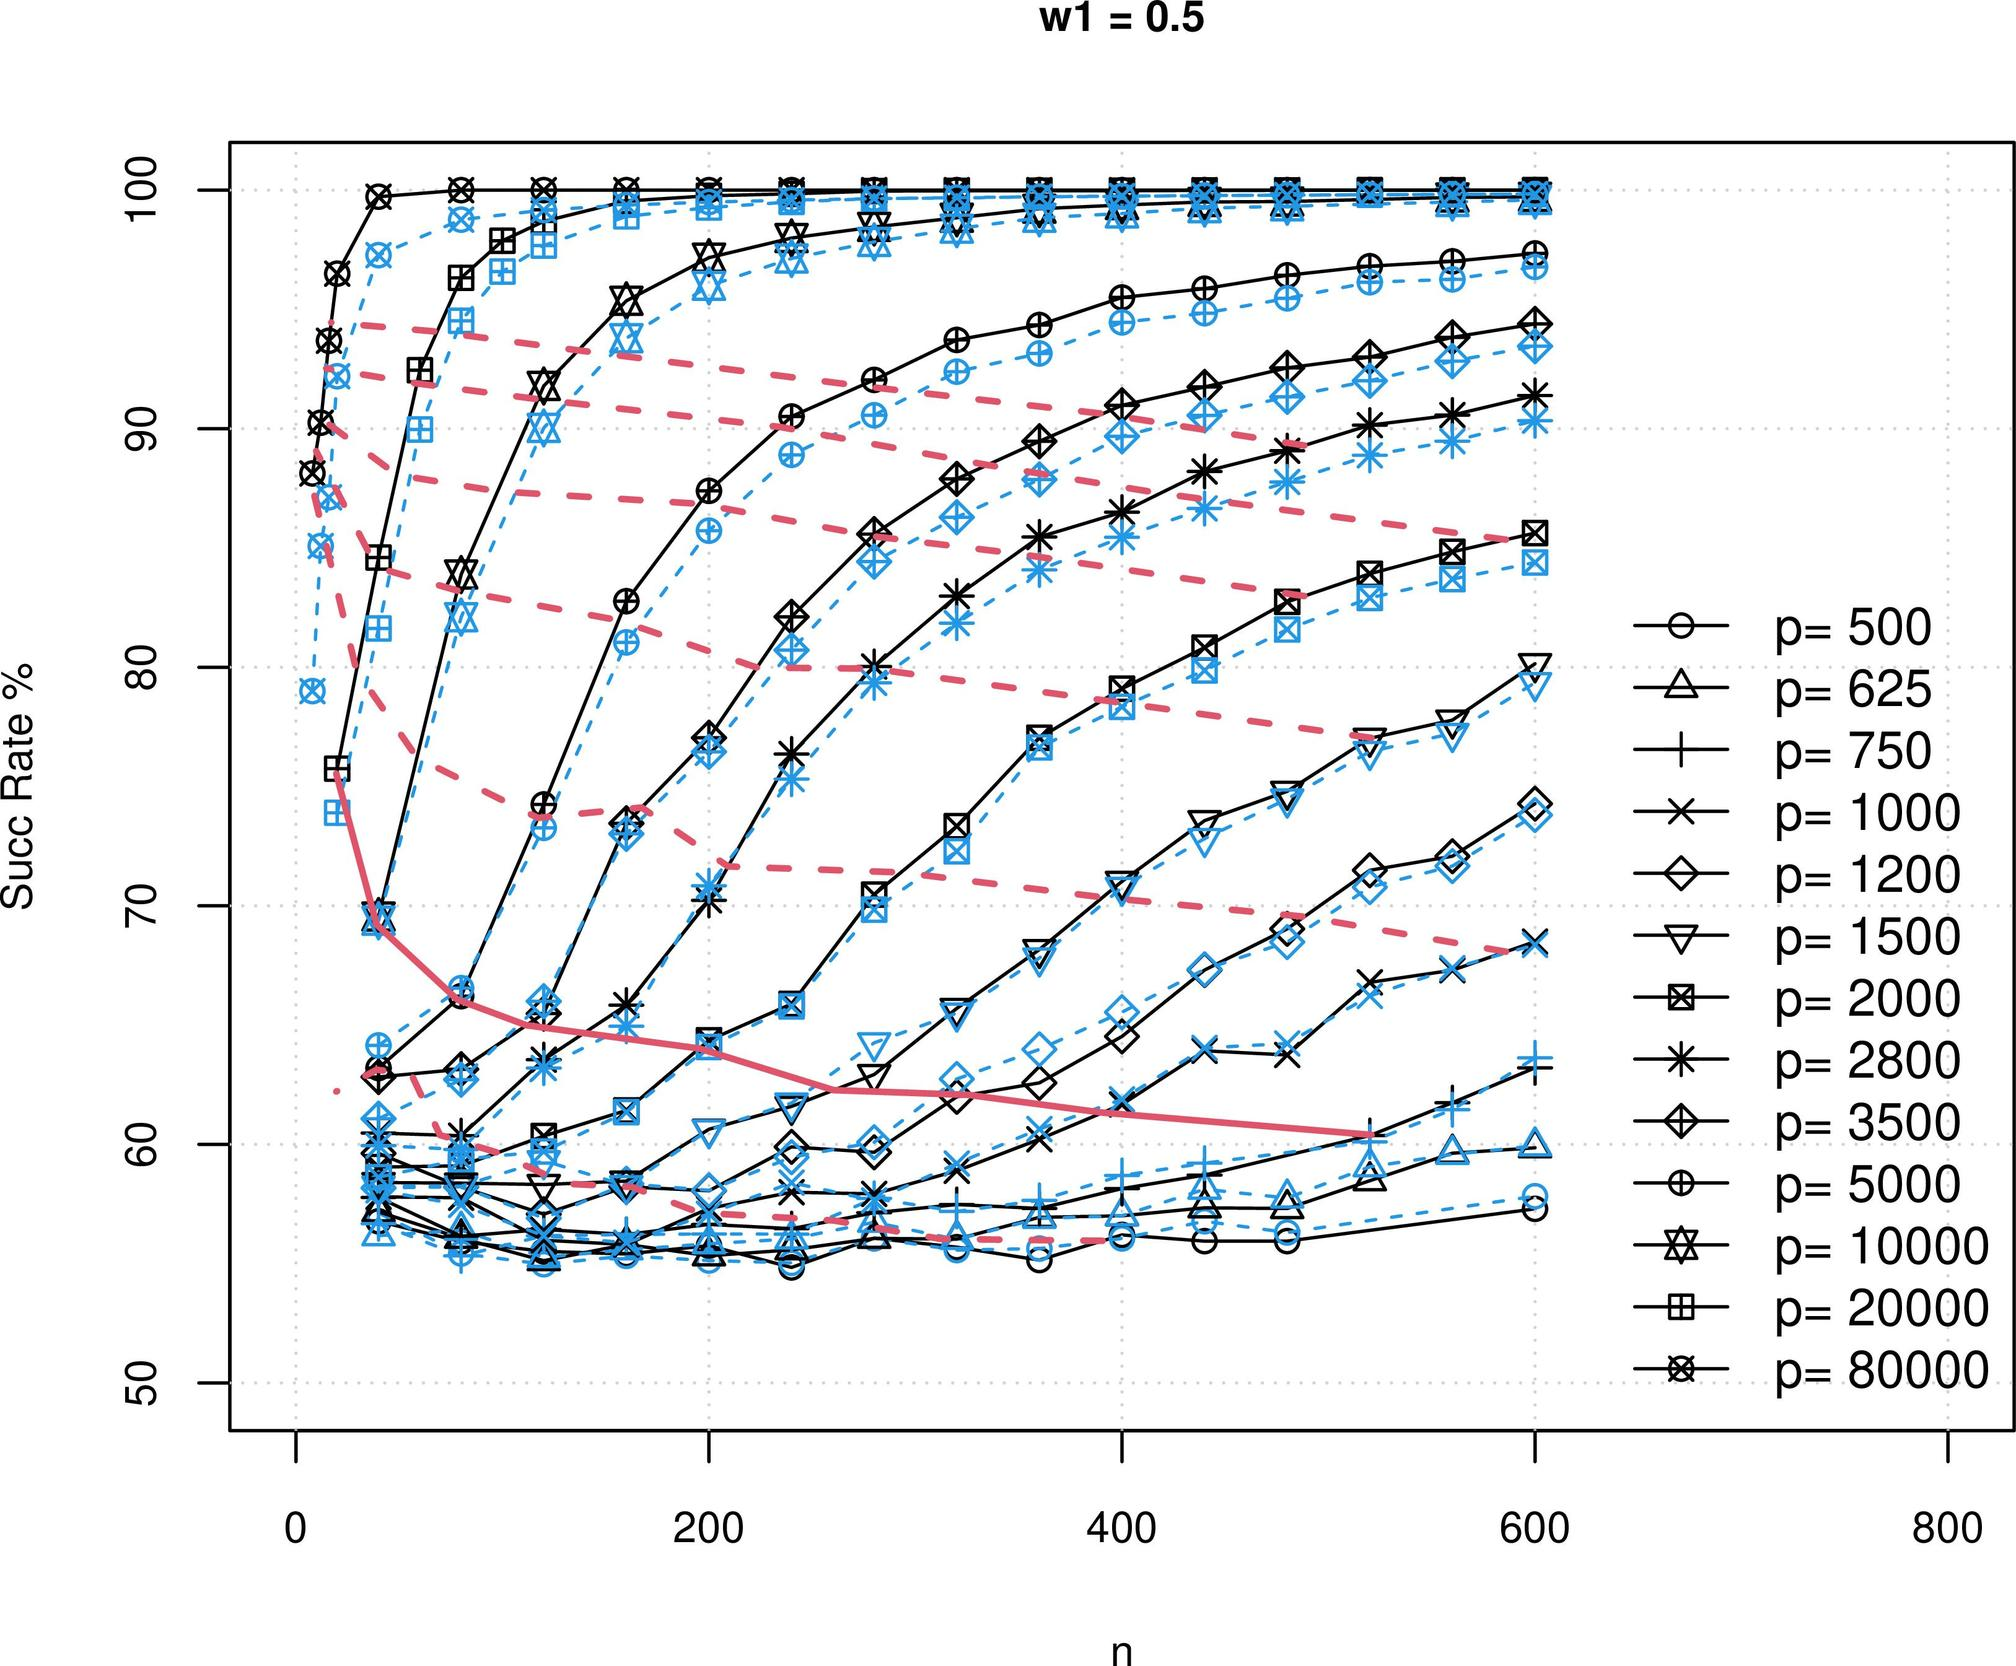What patterns can be observed concerning the maximum success rates achieved at different 'p' and 'n' values? At higher 'n' values, nearly all 'p' values eventually converge toward success rates approaching or reaching 100%. This suggests a saturation effect where beyond certain 'n' thresholds, the marginal gains in success rate diminish and plateau, possibly indicating the upper limits of improvement or the achievement of maximum potential under specified conditions. 